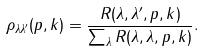Convert formula to latex. <formula><loc_0><loc_0><loc_500><loc_500>\rho _ { \lambda \lambda ^ { \prime } } ( { p } , { k } ) = \frac { R ( \lambda , \lambda ^ { \prime } , { p } , { k } ) } { \sum _ { \lambda } R ( \lambda , \lambda , { p } , { k } ) } .</formula> 